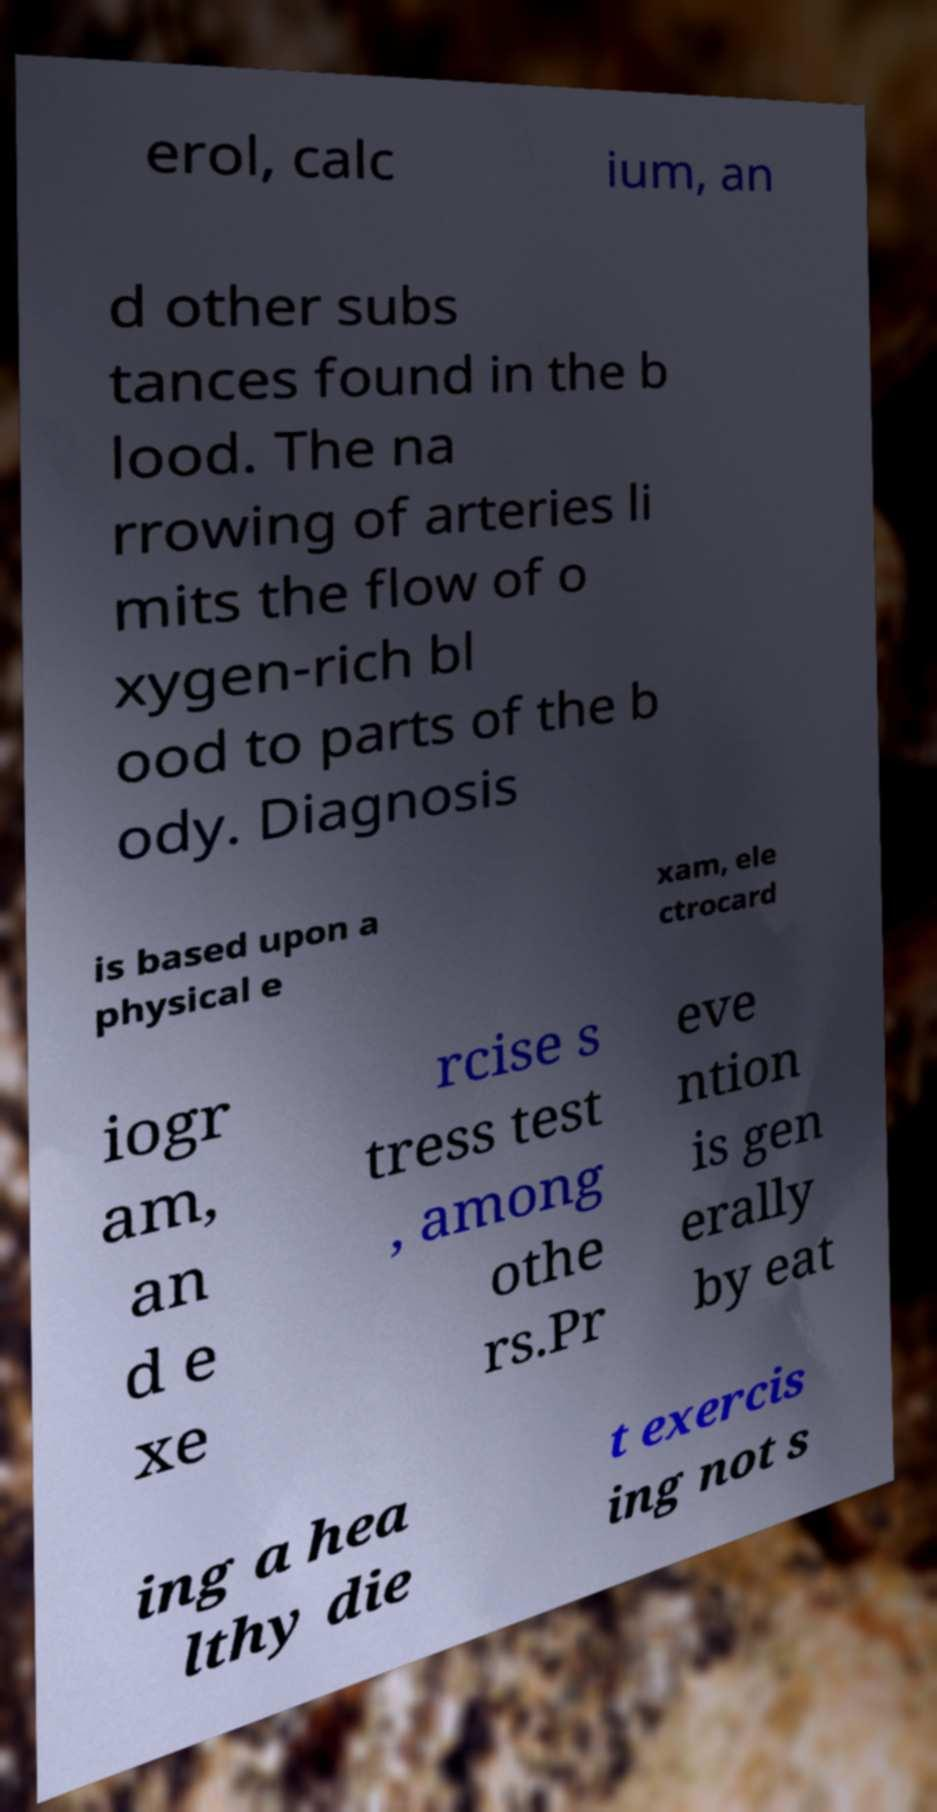Please read and relay the text visible in this image. What does it say? erol, calc ium, an d other subs tances found in the b lood. The na rrowing of arteries li mits the flow of o xygen-rich bl ood to parts of the b ody. Diagnosis is based upon a physical e xam, ele ctrocard iogr am, an d e xe rcise s tress test , among othe rs.Pr eve ntion is gen erally by eat ing a hea lthy die t exercis ing not s 